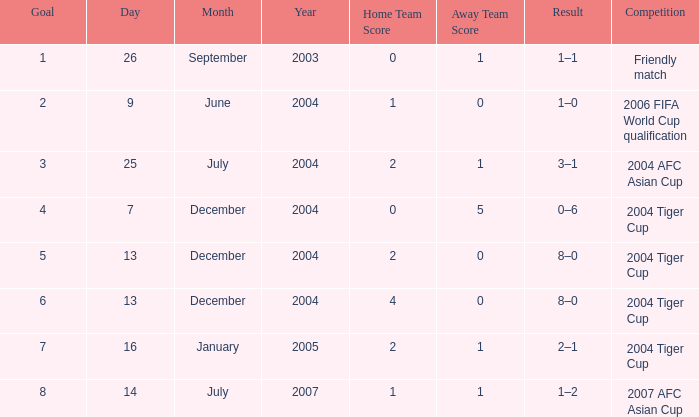Could you help me parse every detail presented in this table? {'header': ['Goal', 'Day', 'Month', 'Year', 'Home Team Score', 'Away Team Score', 'Result', 'Competition'], 'rows': [['1', '26', 'September', '2003', '0', '1', '1–1', 'Friendly match'], ['2', '9', 'June', '2004', '1', '0', '1–0', '2006 FIFA World Cup qualification'], ['3', '25', 'July', '2004', '2', '1', '3–1', '2004 AFC Asian Cup'], ['4', '7', 'December', '2004', '0', '5', '0–6', '2004 Tiger Cup'], ['5', '13', 'December', '2004', '2', '0', '8–0', '2004 Tiger Cup'], ['6', '13', 'December', '2004', '4', '0', '8–0', '2004 Tiger Cup'], ['7', '16', 'January', '2005', '2', '1', '2–1', '2004 Tiger Cup'], ['8', '14', 'July', '2007', '1', '1', '1–2', '2007 AFC Asian Cup']]} Which date has 3 as the goal? 25 July 2004. 